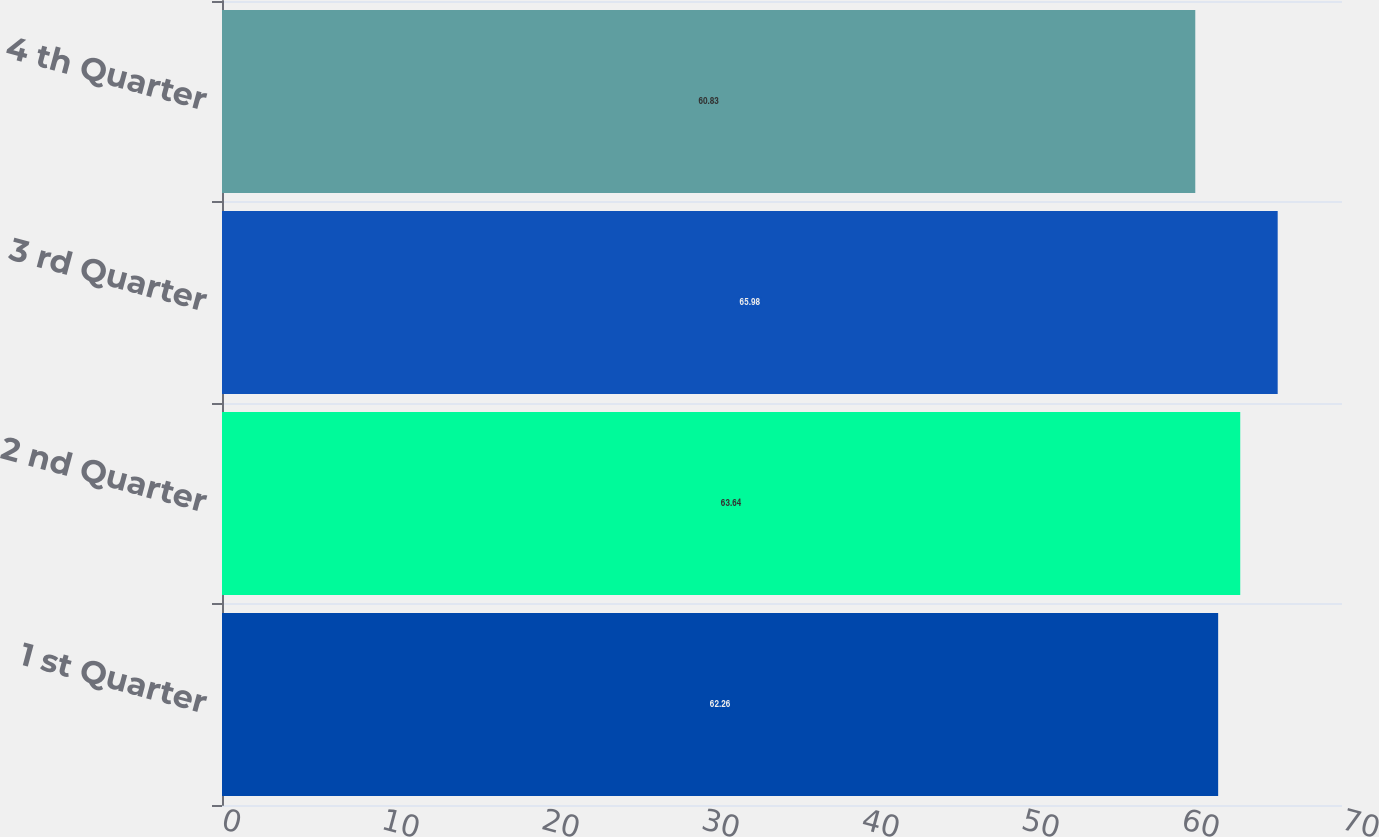Convert chart to OTSL. <chart><loc_0><loc_0><loc_500><loc_500><bar_chart><fcel>1 st Quarter<fcel>2 nd Quarter<fcel>3 rd Quarter<fcel>4 th Quarter<nl><fcel>62.26<fcel>63.64<fcel>65.98<fcel>60.83<nl></chart> 